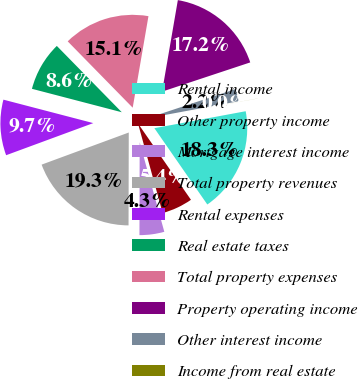Convert chart. <chart><loc_0><loc_0><loc_500><loc_500><pie_chart><fcel>Rental income<fcel>Other property income<fcel>Mortgage interest income<fcel>Total property revenues<fcel>Rental expenses<fcel>Real estate taxes<fcel>Total property expenses<fcel>Property operating income<fcel>Other interest income<fcel>Income from real estate<nl><fcel>18.27%<fcel>5.38%<fcel>4.31%<fcel>19.34%<fcel>9.68%<fcel>8.6%<fcel>15.05%<fcel>17.19%<fcel>2.16%<fcel>0.01%<nl></chart> 